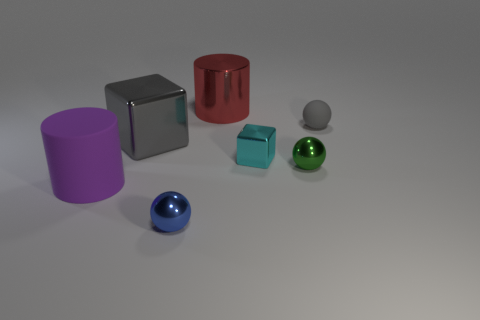There is a red thing that is made of the same material as the big cube; what is its size?
Your response must be concise. Large. There is a gray object that is on the right side of the big red metallic object; what shape is it?
Offer a terse response. Sphere. There is a metal object that is the same shape as the large purple matte object; what is its size?
Ensure brevity in your answer.  Large. What number of big objects are to the left of the cylinder that is on the right side of the gray thing that is in front of the tiny gray rubber ball?
Your answer should be very brief. 2. Are there an equal number of tiny rubber objects behind the shiny cylinder and metallic things?
Provide a short and direct response. No. How many blocks are either tiny things or tiny blue objects?
Offer a terse response. 1. Is the small rubber sphere the same color as the big block?
Offer a terse response. Yes. Are there an equal number of shiny things that are behind the gray block and big shiny cubes that are right of the big red metal cylinder?
Make the answer very short. No. What color is the rubber sphere?
Keep it short and to the point. Gray. How many objects are either metallic things in front of the gray metallic cube or tiny shiny spheres?
Give a very brief answer. 3. 